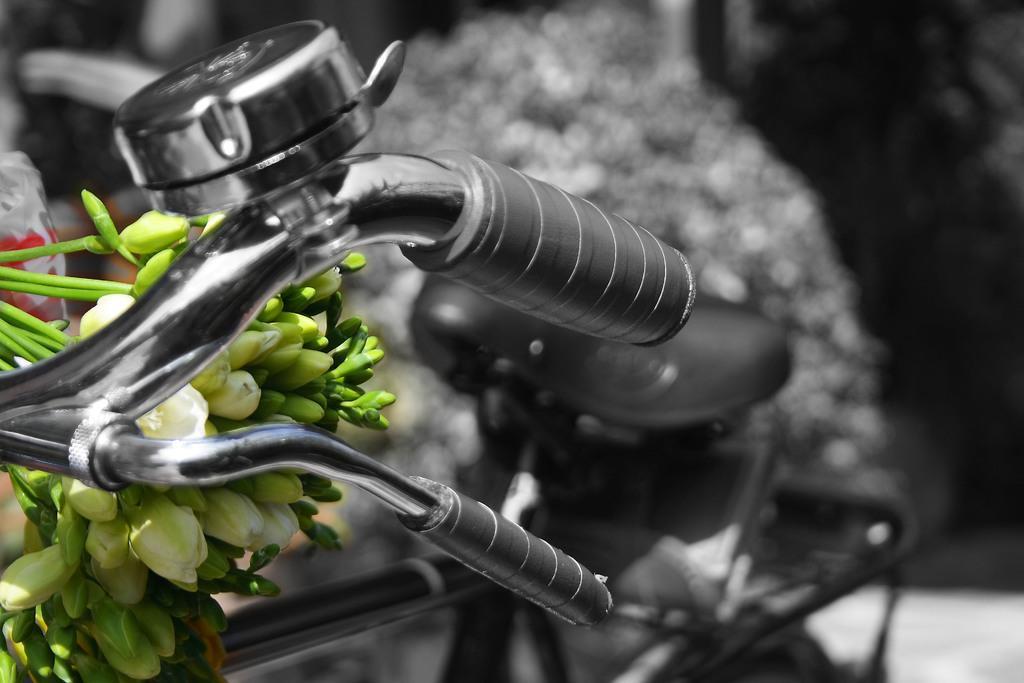Could you give a brief overview of what you see in this image? In the image we can see a bicycle. Behind the bicycle there are some plants. Background of the image is blur. 